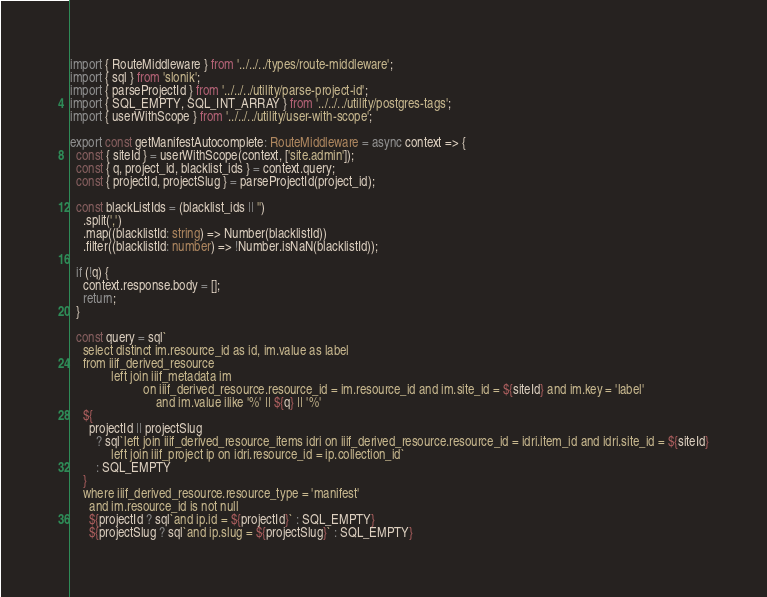Convert code to text. <code><loc_0><loc_0><loc_500><loc_500><_TypeScript_>import { RouteMiddleware } from '../../../types/route-middleware';
import { sql } from 'slonik';
import { parseProjectId } from '../../../utility/parse-project-id';
import { SQL_EMPTY, SQL_INT_ARRAY } from '../../../utility/postgres-tags';
import { userWithScope } from '../../../utility/user-with-scope';

export const getManifestAutocomplete: RouteMiddleware = async context => {
  const { siteId } = userWithScope(context, ['site.admin']);
  const { q, project_id, blacklist_ids } = context.query;
  const { projectId, projectSlug } = parseProjectId(project_id);

  const blackListIds = (blacklist_ids || '')
    .split(',')
    .map((blacklistId: string) => Number(blacklistId))
    .filter((blacklistId: number) => !Number.isNaN(blacklistId));

  if (!q) {
    context.response.body = [];
    return;
  }

  const query = sql`
    select distinct im.resource_id as id, im.value as label
    from iiif_derived_resource
             left join iiif_metadata im
                       on iiif_derived_resource.resource_id = im.resource_id and im.site_id = ${siteId} and im.key = 'label'
                           and im.value ilike '%' || ${q} || '%'
    ${
      projectId || projectSlug
        ? sql`left join iiif_derived_resource_items idri on iiif_derived_resource.resource_id = idri.item_id and idri.site_id = ${siteId}
             left join iiif_project ip on idri.resource_id = ip.collection_id`
        : SQL_EMPTY
    }
    where iiif_derived_resource.resource_type = 'manifest'
      and im.resource_id is not null
      ${projectId ? sql`and ip.id = ${projectId}` : SQL_EMPTY}
      ${projectSlug ? sql`and ip.slug = ${projectSlug}` : SQL_EMPTY}</code> 